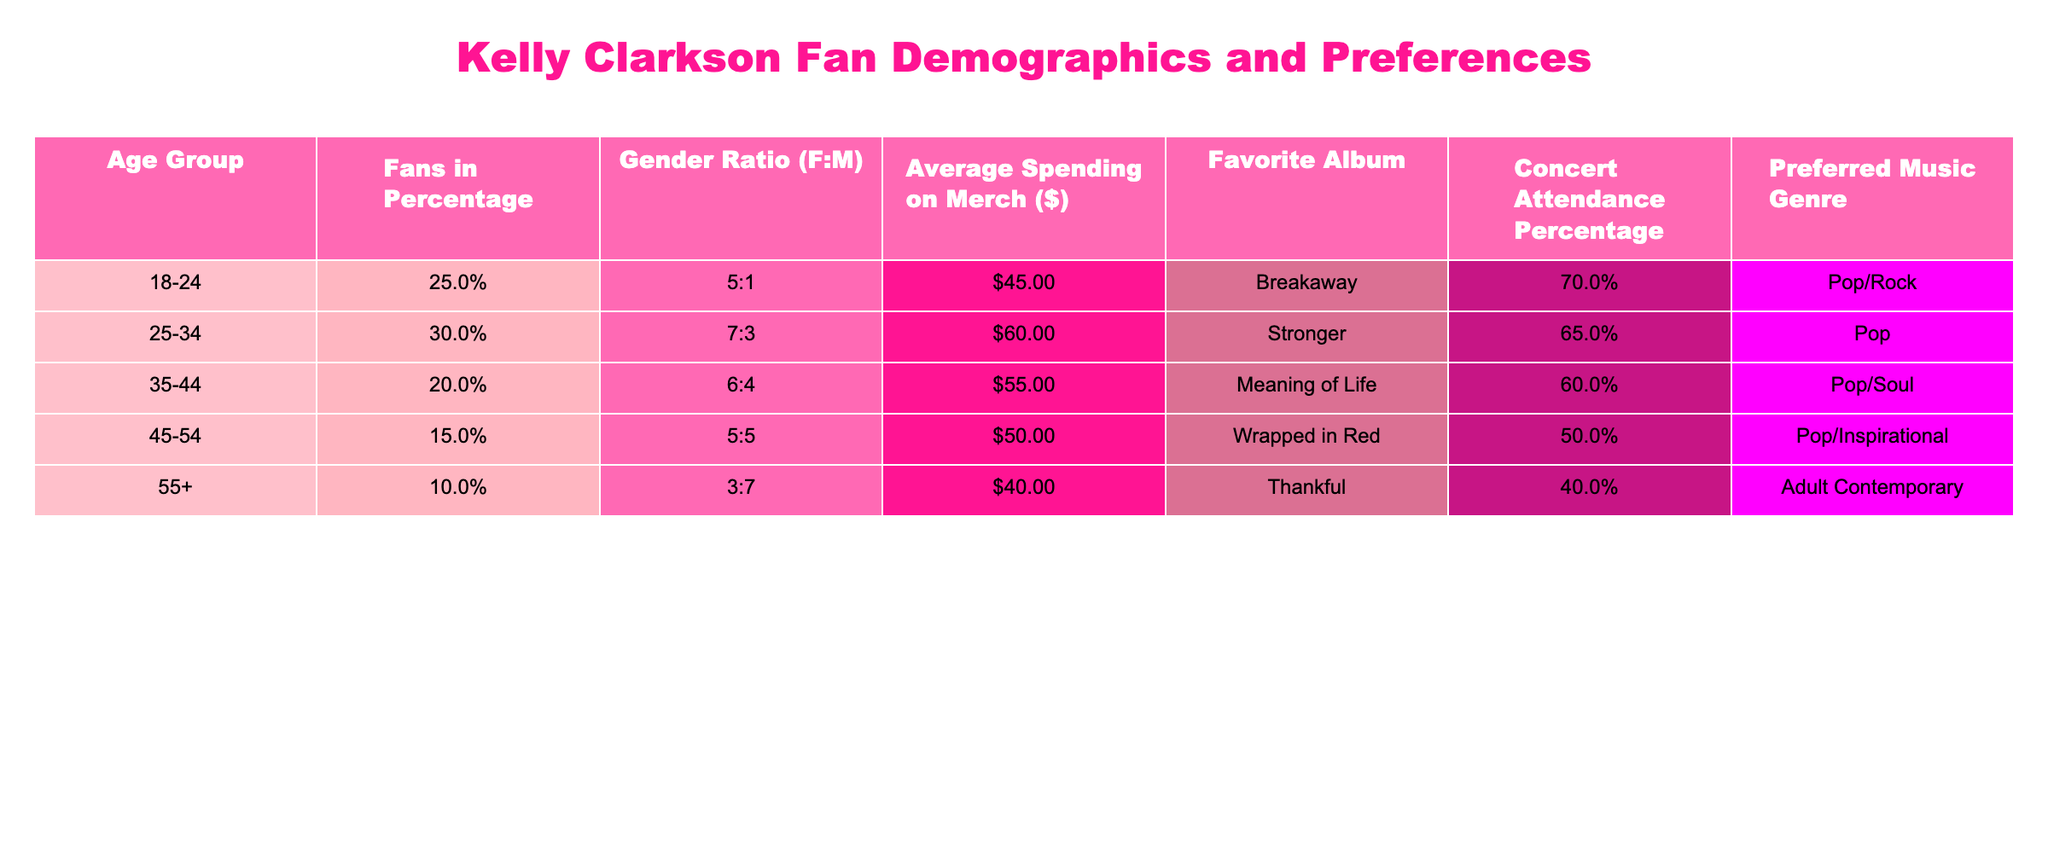What's the percentage of fans in the 25-34 age group? According to the table, the "Fans in Percentage" for the 25-34 age group is directly listed as 30.0%.
Answer: 30.0% Which age group has the highest average spending on merchandise? By comparing the "Average Spending on Merch ($)" values, the 25-34 age group has the highest amount at $60.00.
Answer: 25-34 What is the concert attendance percentage of fans aged 45-54? The table shows that the "Concert Attendance Percentage" for the 45-54 age group is 50.0%.
Answer: 50.0% What is the gender ratio of fans aged 35-44? The "Gender Ratio (F:M)" for the 35-44 age group is indicated as 6:4.
Answer: 6:4 How many total fans (in percentage) are aged 18-24 and 45-54 combined? Adding the percentages for the 18-24 (25.0%) and 45-54 (15.0%) age groups gives a total of 40.0%.
Answer: 40.0% Is the favorite album of fans in the 55+ age group "Thankful"? The table states that the "Favorite Album" for the 55+ age group is indeed "Thankful".
Answer: Yes What is the gender ratio difference between the 18-24 and 35-44 age groups? The ratio for 18-24 is 5:1 and for 35-44 is 6:4. Converting these ratios shows that 18-24 has 5 females for every 1 male (5/1) while 35-44 has 6 females for every 4 males (6/4 = 1.5). The difference can be seen as 5:1 (or 5) for 18-24 and 1.5 for 35-44, which shows a difference in female fans.
Answer: 5:1 more females What is the overall average spending on merchandise for all age groups combined? To find this, we calculate the weighted average: (25% * 45 + 30% * 60 + 20% * 55 + 15% * 50 + 10% * 40) = 11.25 + 18 + 11 + 7.5 + 4 = 51.75. The overall average is approximately $51.75.
Answer: $51.75 Are the fans who prefer "Pop/Rock" more numerous than those who prefer "Pop"? The "Fans in Percentage" for "Pop/Rock" (18-24, 25.0%) is less than for "Pop" (25-34, 30.0%). Therefore, yes, more fans prefer "Pop".
Answer: Yes What is the favorite album for the age group with the lowest percentage of fans? The lowest percentage of fans is in the 55+ age group, and their favorite album is "Thankful".
Answer: Thankful 